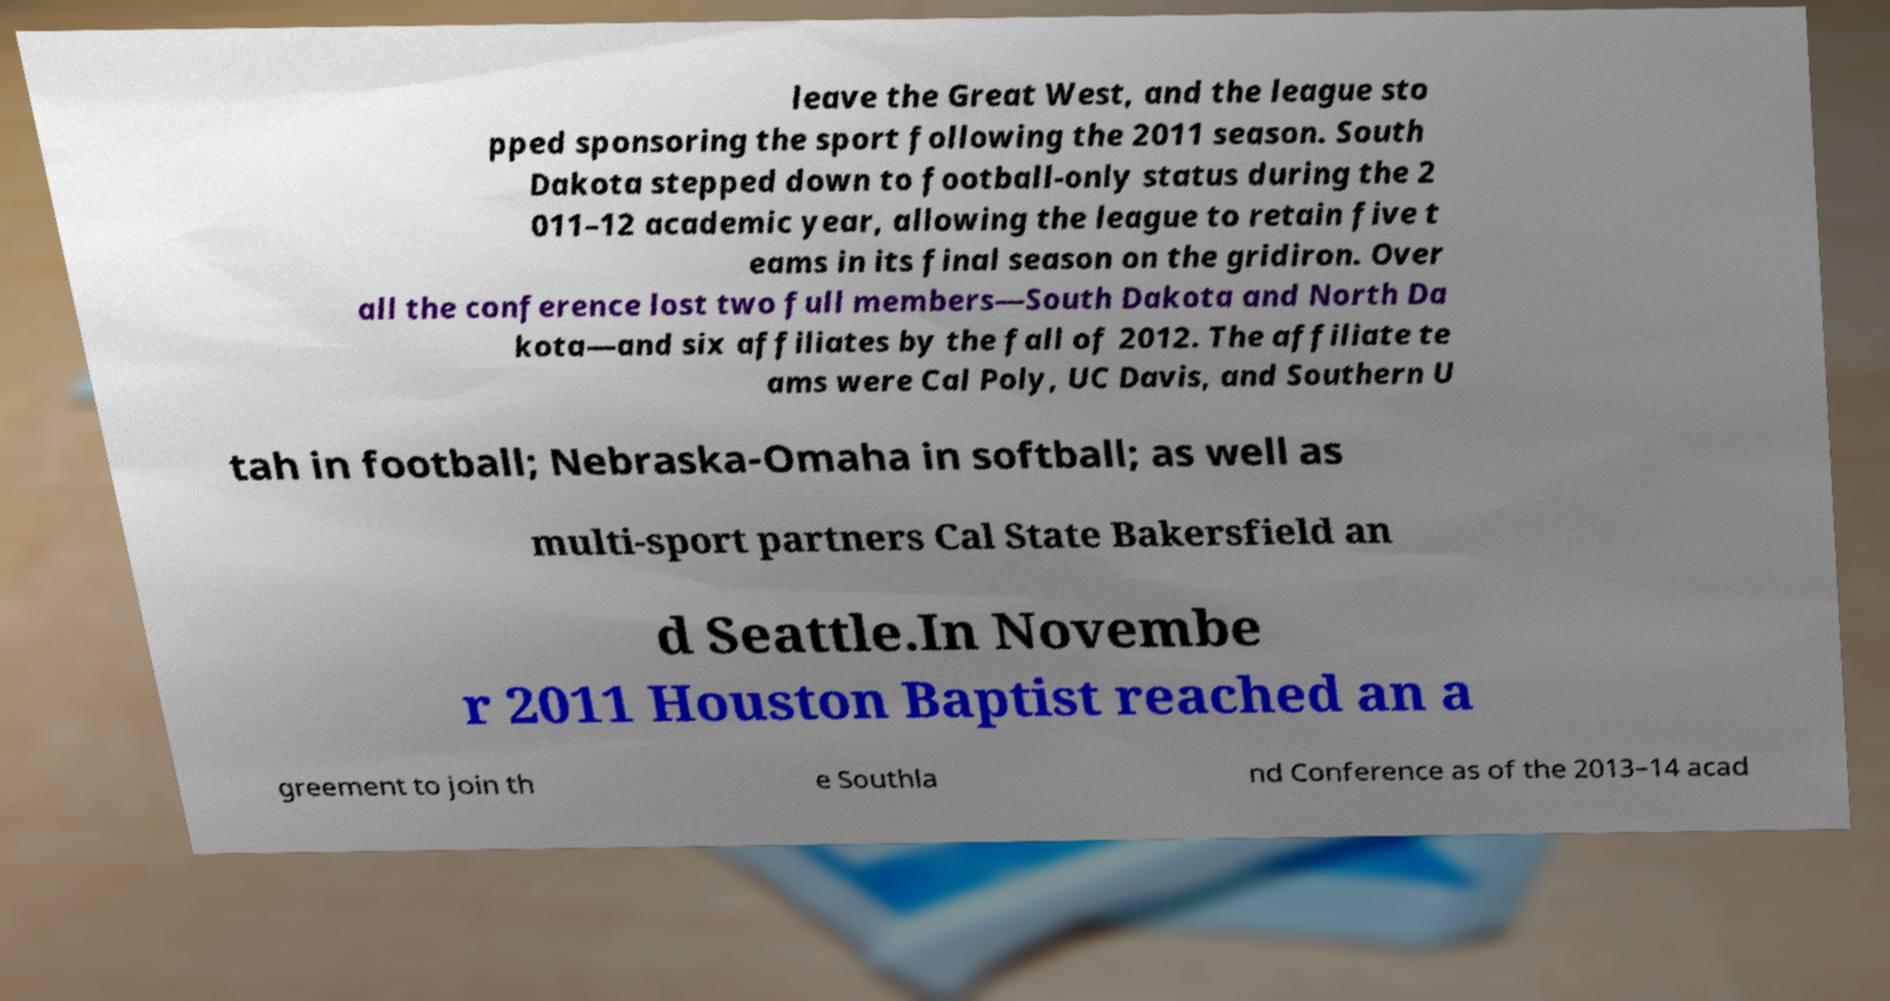Please read and relay the text visible in this image. What does it say? leave the Great West, and the league sto pped sponsoring the sport following the 2011 season. South Dakota stepped down to football-only status during the 2 011–12 academic year, allowing the league to retain five t eams in its final season on the gridiron. Over all the conference lost two full members—South Dakota and North Da kota—and six affiliates by the fall of 2012. The affiliate te ams were Cal Poly, UC Davis, and Southern U tah in football; Nebraska-Omaha in softball; as well as multi-sport partners Cal State Bakersfield an d Seattle.In Novembe r 2011 Houston Baptist reached an a greement to join th e Southla nd Conference as of the 2013–14 acad 